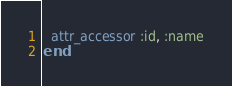<code> <loc_0><loc_0><loc_500><loc_500><_Ruby_>  attr_accessor :id, :name
end</code> 